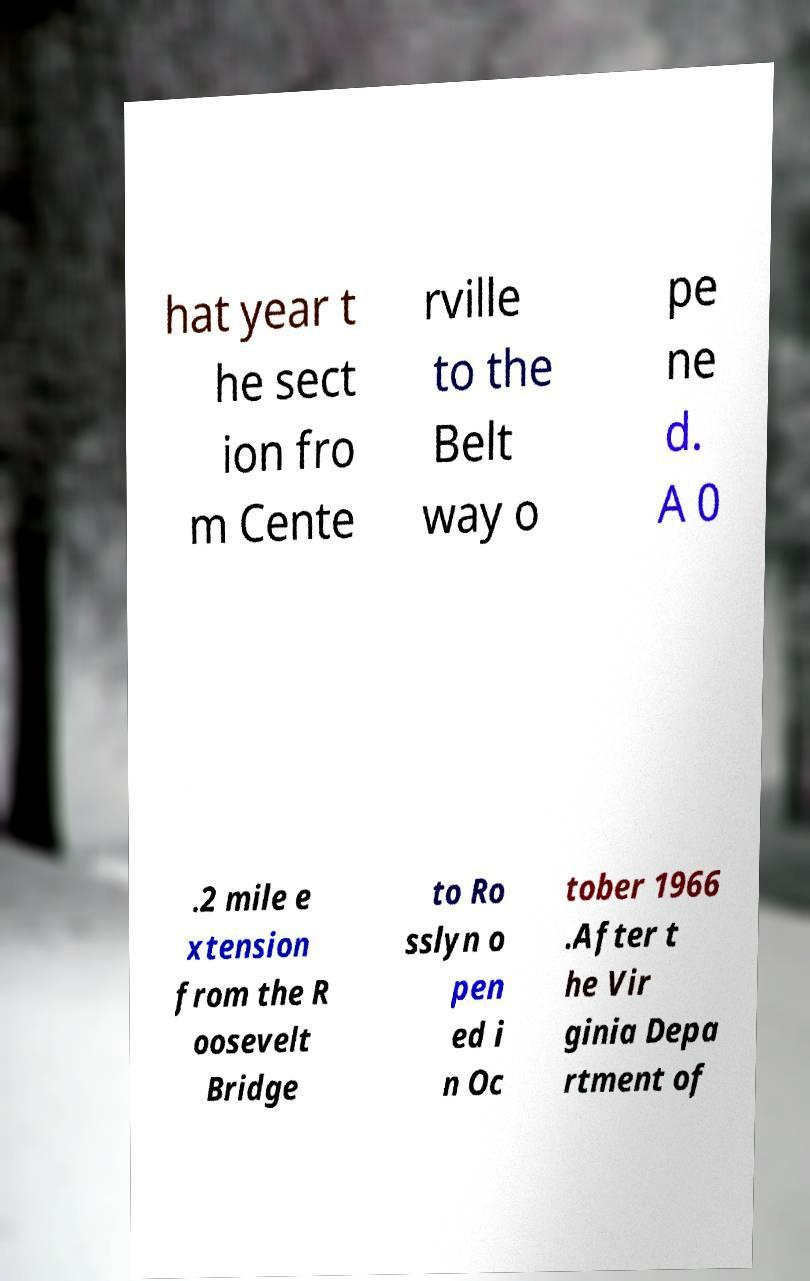I need the written content from this picture converted into text. Can you do that? hat year t he sect ion fro m Cente rville to the Belt way o pe ne d. A 0 .2 mile e xtension from the R oosevelt Bridge to Ro sslyn o pen ed i n Oc tober 1966 .After t he Vir ginia Depa rtment of 